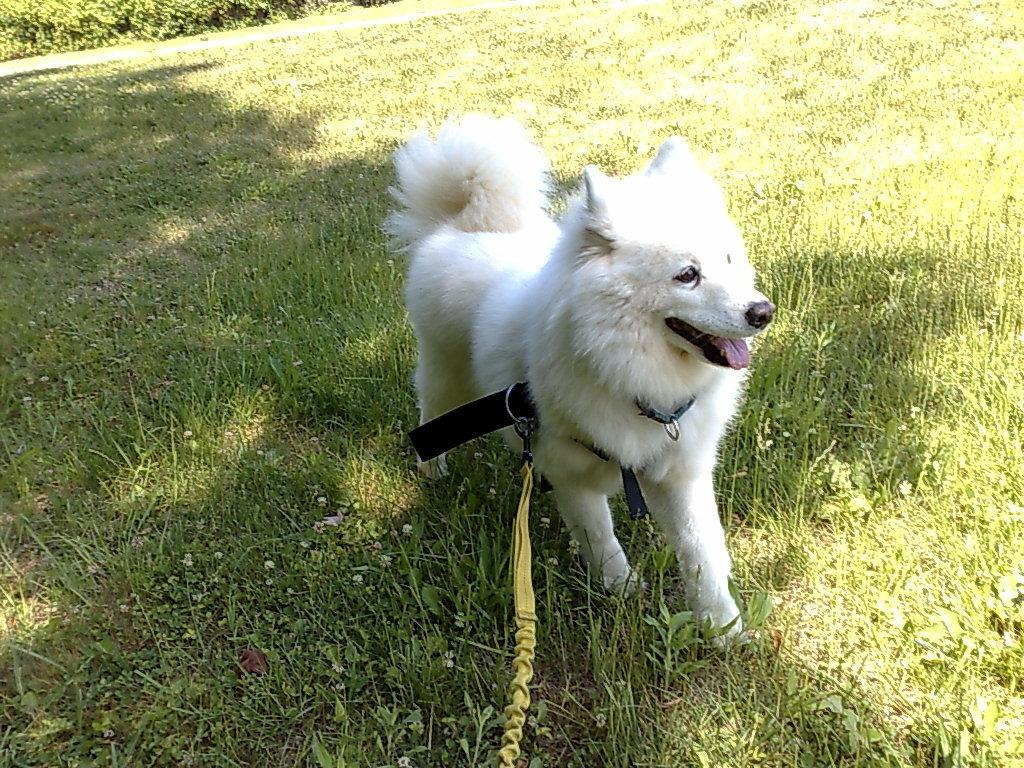What is the main subject in the center of the image? There is a dog in the center of the image. What type of surface is at the bottom of the image? There is grass at the bottom of the image. What accessory is present in the image? There is a belt in the image. What can be seen in the background of the image? There are plants in the background of the image. How does the scarecrow change its appearance in the image? There is no scarecrow present in the image, so it cannot change its appearance. 